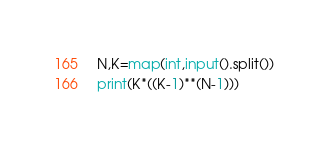Convert code to text. <code><loc_0><loc_0><loc_500><loc_500><_Python_>N,K=map(int,input().split())
print(K*((K-1)**(N-1)))</code> 